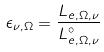<formula> <loc_0><loc_0><loc_500><loc_500>\epsilon _ { \nu , \Omega } = \frac { L _ { e , \Omega , \nu } } { L _ { e , \Omega , \nu } ^ { \circ } }</formula> 